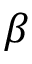Convert formula to latex. <formula><loc_0><loc_0><loc_500><loc_500>\beta</formula> 